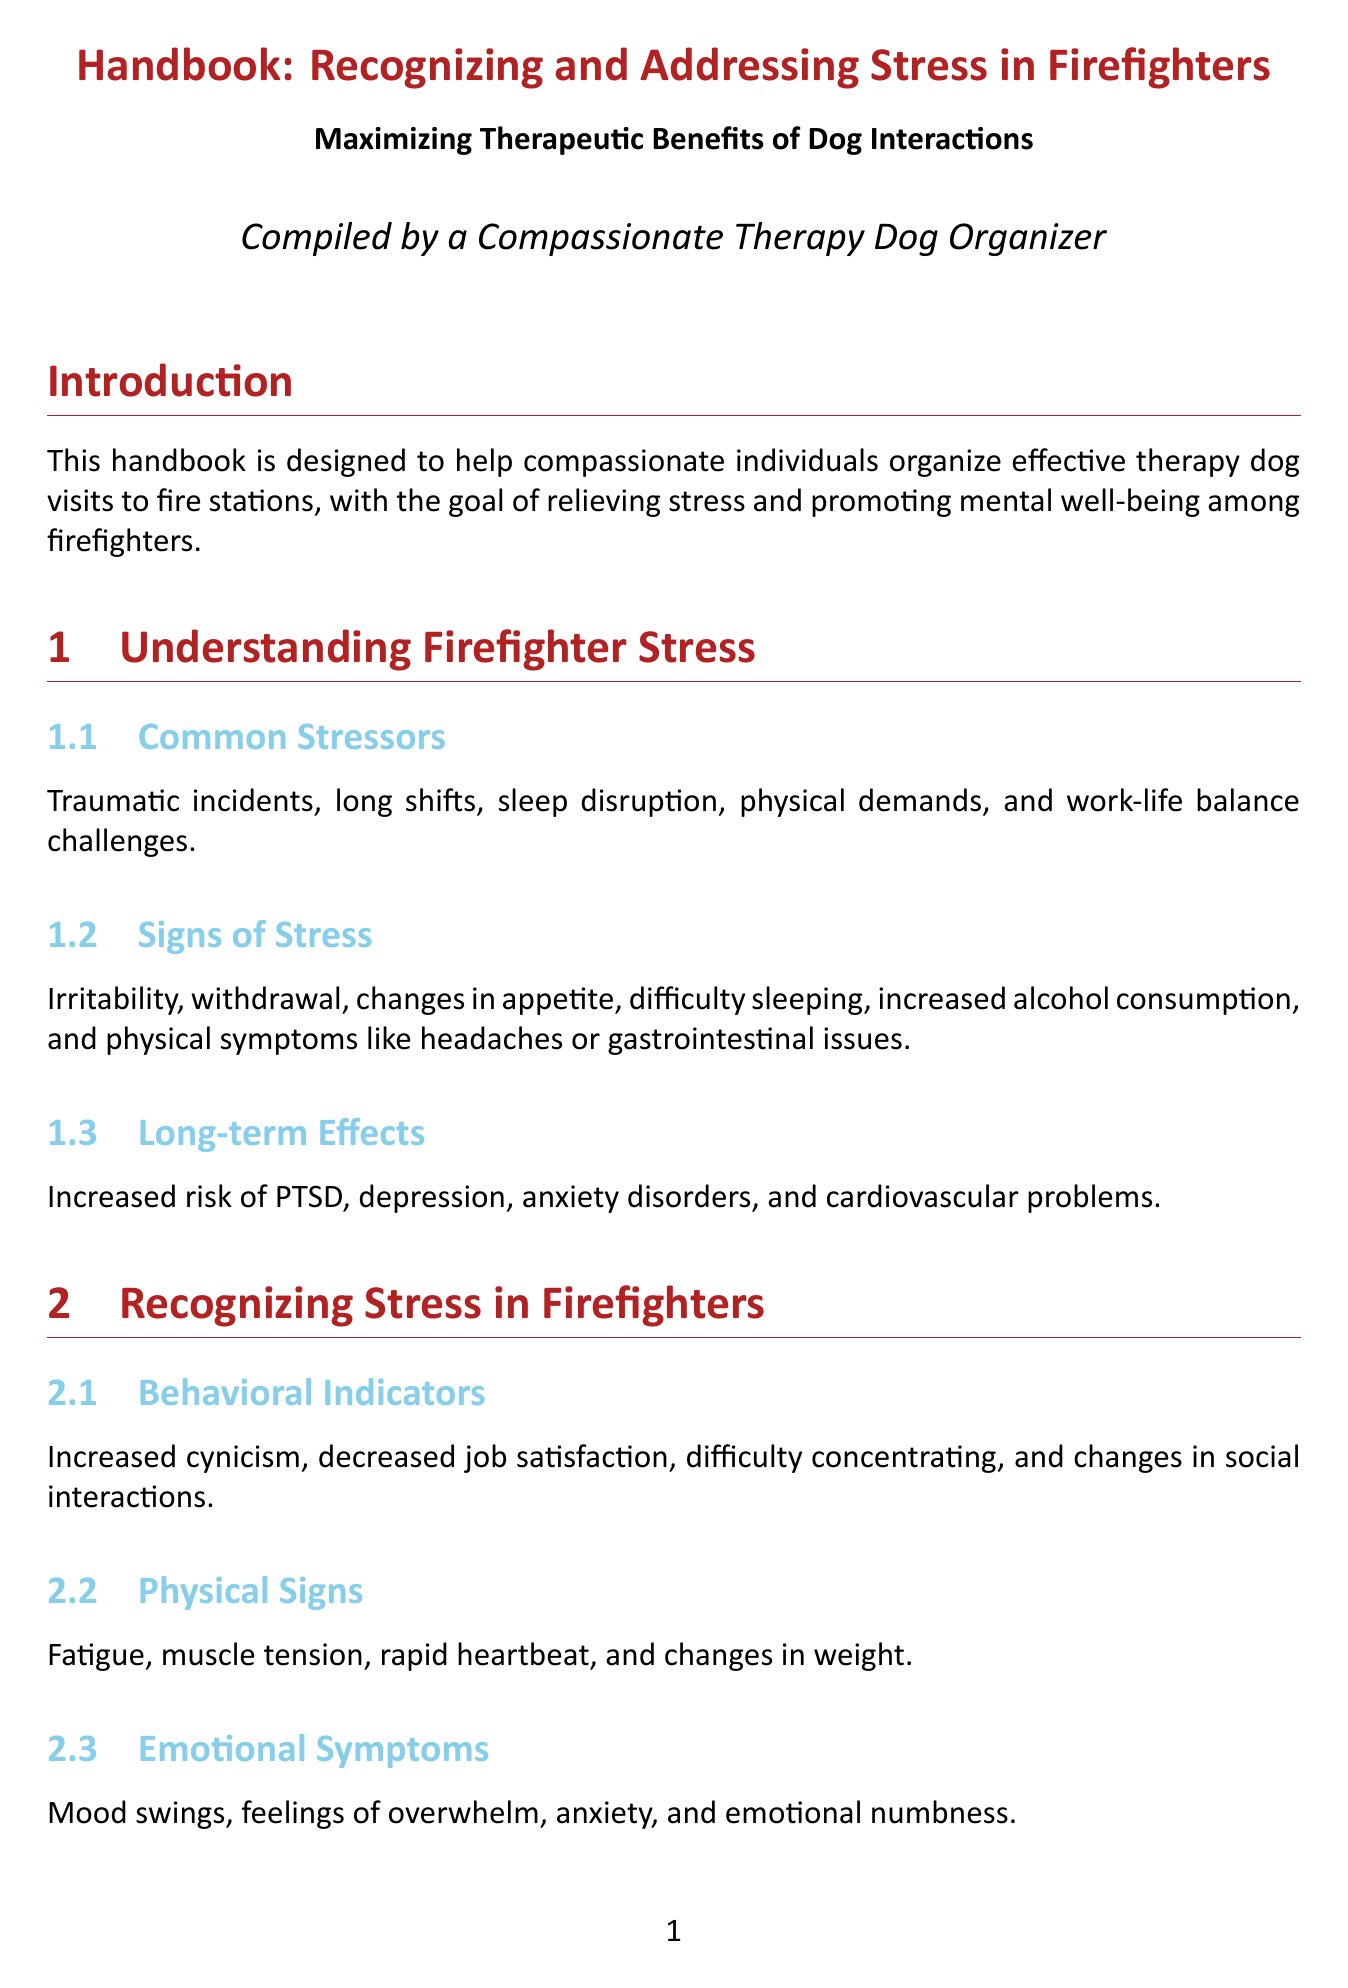What is the title of the handbook? The title provides the main subject of the document, which is about recognizing and addressing stress in firefighters and the role of therapy dogs.
Answer: Handbook: Recognizing and Addressing Stress in Firefighters - Maximizing Therapeutic Benefits of Dog Interactions What is one common stressor for firefighters? This question asks for specific information mentioned in the section about stressors affecting firefighters.
Answer: Traumatic incidents What are firefighters encouraged to do for stress management? This question relates to the recommended techniques within the document for addressing stress among firefighters.
Answer: Teach mindfulness What physiological effect do therapy dogs have on firefighters? This question focuses on the specific benefits outlined in the document regarding therapy dog interactions.
Answer: Decreased blood pressure How long should therapy dog interaction sessions be? This question requires information from the section detailing how to structure the interaction with therapy dogs.
Answer: 15-30 minutes Which organization is recommended for selecting therapy dogs? This question relates to the guidelines set forth in the handbook regarding the selection of therapy dogs.
Answer: Therapy Dogs International What is a recommended lifestyle change for firefighters? This question is directed towards the lifestyle recommendations made in the document to help address firefighter stress.
Answer: Regular exercise What should be ensured for hygiene and safety during dog visits? This question looks for a specific practice mentioned in the document related to the health protocols for therapy dog interactions.
Answer: Up-to-date vaccinations 